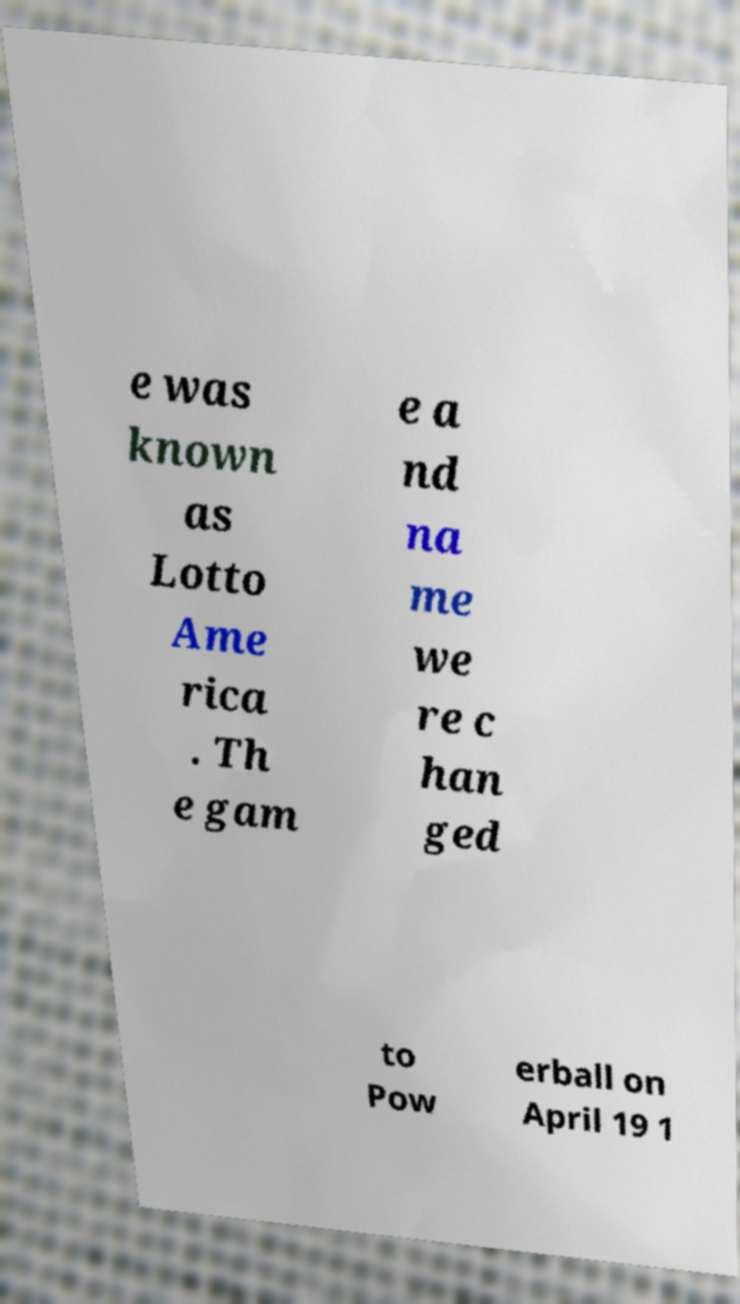There's text embedded in this image that I need extracted. Can you transcribe it verbatim? e was known as Lotto Ame rica . Th e gam e a nd na me we re c han ged to Pow erball on April 19 1 